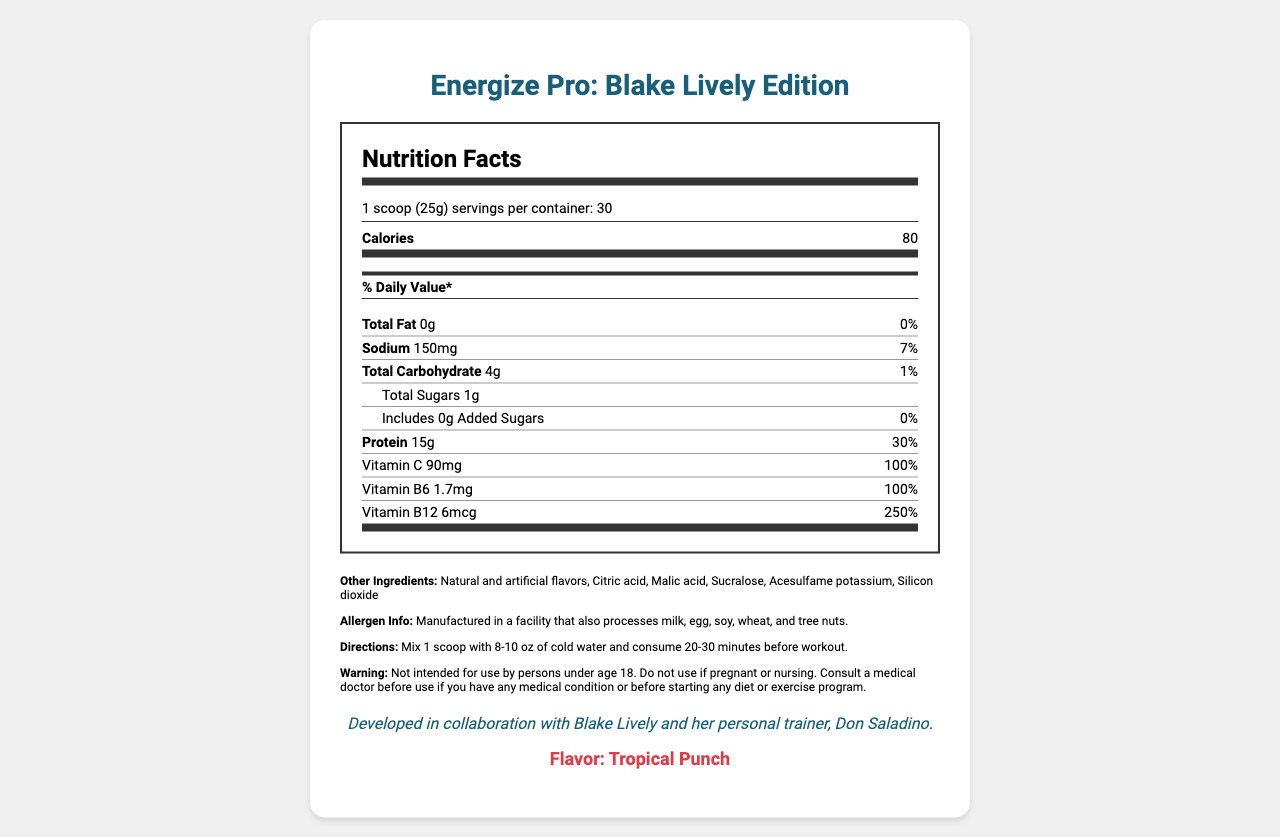what is the serving size? The serving size is explicitly stated in the document as 1 scoop (25g).
Answer: 1 scoop (25g) how many servings are in the container? The document specifies that there are 30 servings per container.
Answer: 30 how many calories are in one serving? The calories per serving are listed directly as 80.
Answer: 80 what is the amount of protein in one serving? The protein amount per serving is given as 15g in the document.
Answer: 15g how much sodium is in one serving? The document lists the sodium content per serving as 150mg.
Answer: 150mg what is the daily value percentage for vitamin C? The daily value percentage for vitamin C is stated as 100%.
Answer: 100% how many grams of total carbohydrate are there in one serving? The total carbohydrate amount in one serving is listed as 4g.
Answer: 4g which sweeteners are used in the product? A. Aspartame and Stevia B. Sucralose and Acesulfame Potassium C. Saccharin and Cyclamate The document states that the product contains Sucralose and Acesulfame Potassium.
Answer: B what is the amount of caffeine in one serving? A. 150mg B. 200mg C. 250mg D. 300mg The caffeine content is explicitly listed as 200mg.
Answer: B does the product contain any added sugars? The document mentions that there are 0g of added sugars.
Answer: No what are the directions for using this supplement? The usage directions are clearly stated in the document.
Answer: Mix 1 scoop with 8-10 oz of cold water and consume 20-30 minutes before workout. is this product suitable for someone under 18 years old? The warning section indicates that the product is not intended for use by persons under age 18.
Answer: No who collaborated on the development of this supplement? The document states that the supplement was developed in collaboration with Blake Lively and her personal trainer, Don Saladino.
Answer: Blake Lively and her personal trainer, Don Saladino. describe the flavor of this supplement. The flavor is explicitly mentioned as Tropical Punch.
Answer: Tropical Punch what is the total amount of beta-alanine in one serving? The document lists the beta-alanine content as 3.2g.
Answer: 3.2g is there any information about the price of this supplement? The document does not provide any details about the price of the supplement.
Answer: Not enough information summarize the general nutritional profile of "Energize Pro: Blake Lively Edition." The document provides detailed nutritional information, ingredient list, and other details to give a comprehensive overview of the supplement.
Answer: "Energize Pro: Blake Lively Edition" is a pre-workout supplement with notable ingredients such as 200mg of caffeine, 15g of protein, and various vitamins such as vitamin C (100% DV) and vitamin B12 (250% DV). It contains no fat, minimal carbohydrates (4g per serving), and 150mg of sodium. This product is formulated without added sugars and includes distinct ingredients like beta-alanine, citrulline malate, creatine monohydrate, l-tyrosine, taurine, and bioperine. It has a Tropical Punch flavor and comes with specific usage directions and warnings. 